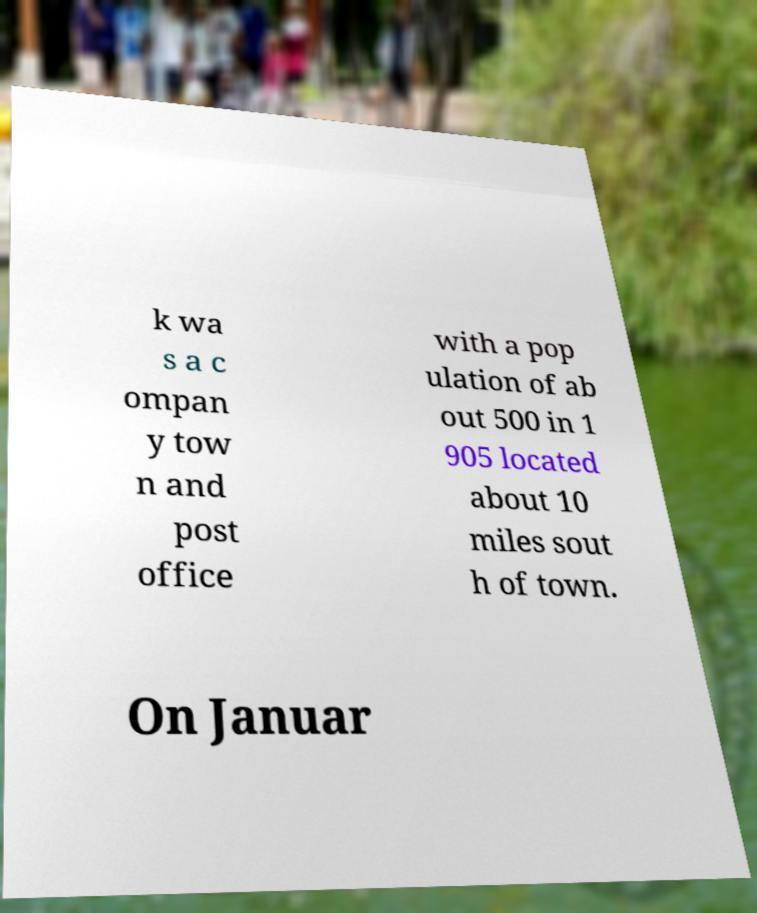Could you extract and type out the text from this image? k wa s a c ompan y tow n and post office with a pop ulation of ab out 500 in 1 905 located about 10 miles sout h of town. On Januar 